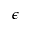<formula> <loc_0><loc_0><loc_500><loc_500>\epsilon</formula> 